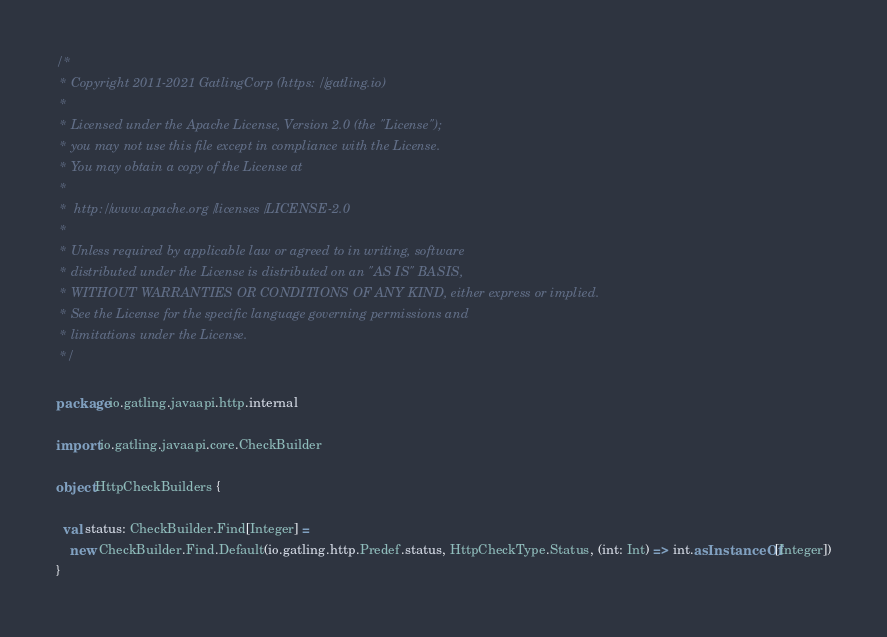<code> <loc_0><loc_0><loc_500><loc_500><_Scala_>/*
 * Copyright 2011-2021 GatlingCorp (https://gatling.io)
 *
 * Licensed under the Apache License, Version 2.0 (the "License");
 * you may not use this file except in compliance with the License.
 * You may obtain a copy of the License at
 *
 *  http://www.apache.org/licenses/LICENSE-2.0
 *
 * Unless required by applicable law or agreed to in writing, software
 * distributed under the License is distributed on an "AS IS" BASIS,
 * WITHOUT WARRANTIES OR CONDITIONS OF ANY KIND, either express or implied.
 * See the License for the specific language governing permissions and
 * limitations under the License.
 */

package io.gatling.javaapi.http.internal

import io.gatling.javaapi.core.CheckBuilder

object HttpCheckBuilders {

  val status: CheckBuilder.Find[Integer] =
    new CheckBuilder.Find.Default(io.gatling.http.Predef.status, HttpCheckType.Status, (int: Int) => int.asInstanceOf[Integer])
}
</code> 